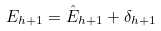<formula> <loc_0><loc_0><loc_500><loc_500>E _ { h + 1 } = \hat { E } _ { h + 1 } + \delta _ { h + 1 }</formula> 